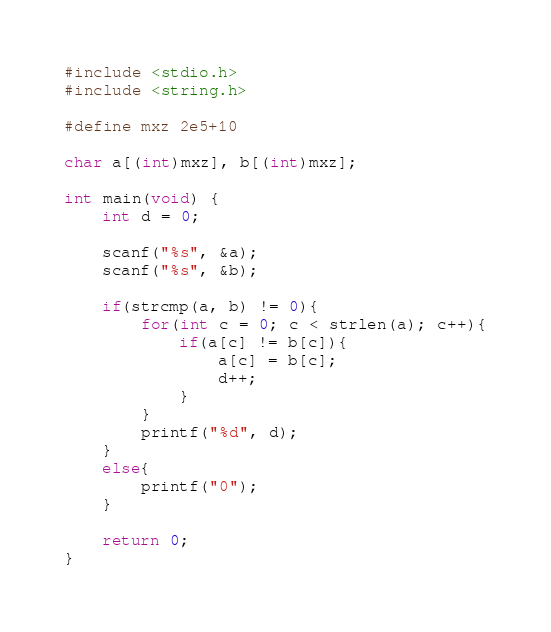Convert code to text. <code><loc_0><loc_0><loc_500><loc_500><_C_>#include <stdio.h>
#include <string.h>

#define mxz 2e5+10

char a[(int)mxz], b[(int)mxz];

int main(void) {
	int d = 0;

	scanf("%s", &a);
	scanf("%s", &b);

	if(strcmp(a, b) != 0){
		for(int c = 0; c < strlen(a); c++){
			if(a[c] != b[c]){
				a[c] = b[c];
				d++;
			}
		}
		printf("%d", d);
	}
	else{
		printf("0");
	}

	return 0;
}
</code> 